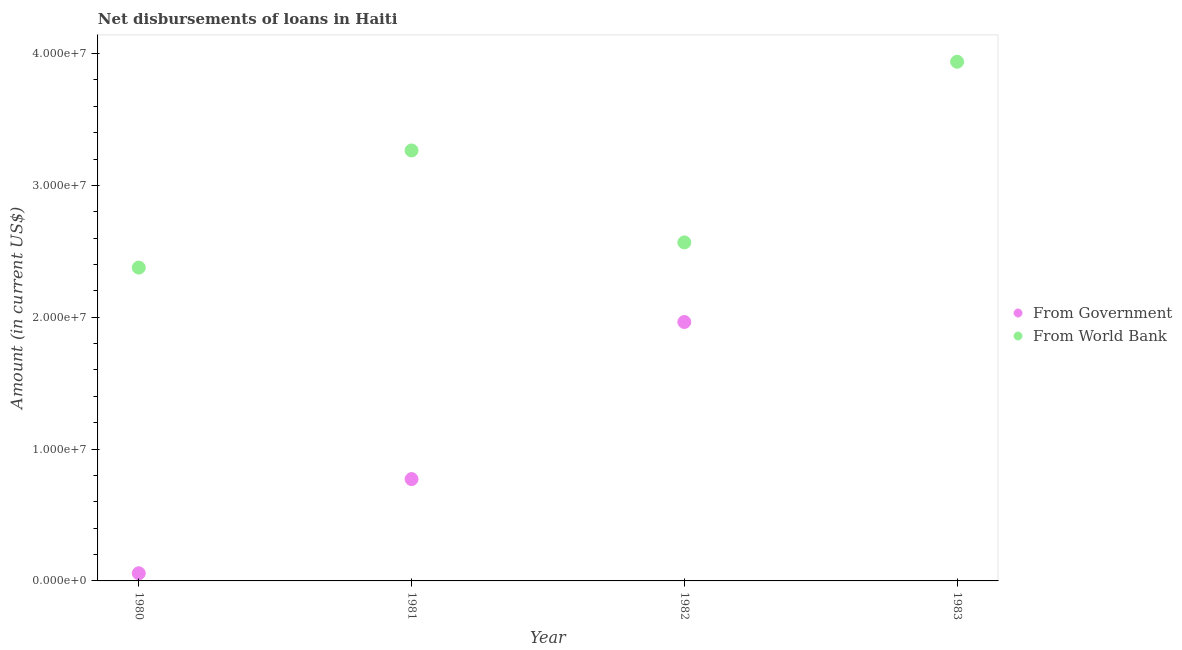What is the net disbursements of loan from world bank in 1983?
Provide a succinct answer. 3.94e+07. Across all years, what is the maximum net disbursements of loan from world bank?
Offer a terse response. 3.94e+07. Across all years, what is the minimum net disbursements of loan from world bank?
Provide a short and direct response. 2.38e+07. In which year was the net disbursements of loan from world bank maximum?
Offer a terse response. 1983. What is the total net disbursements of loan from government in the graph?
Your response must be concise. 2.79e+07. What is the difference between the net disbursements of loan from world bank in 1981 and that in 1982?
Make the answer very short. 6.97e+06. What is the difference between the net disbursements of loan from government in 1983 and the net disbursements of loan from world bank in 1980?
Your answer should be very brief. -2.38e+07. What is the average net disbursements of loan from government per year?
Your response must be concise. 6.99e+06. In the year 1982, what is the difference between the net disbursements of loan from world bank and net disbursements of loan from government?
Ensure brevity in your answer.  6.04e+06. In how many years, is the net disbursements of loan from world bank greater than 16000000 US$?
Your response must be concise. 4. What is the ratio of the net disbursements of loan from government in 1980 to that in 1981?
Keep it short and to the point. 0.08. What is the difference between the highest and the second highest net disbursements of loan from world bank?
Ensure brevity in your answer.  6.73e+06. What is the difference between the highest and the lowest net disbursements of loan from government?
Make the answer very short. 1.96e+07. In how many years, is the net disbursements of loan from government greater than the average net disbursements of loan from government taken over all years?
Keep it short and to the point. 2. Is the sum of the net disbursements of loan from government in 1981 and 1982 greater than the maximum net disbursements of loan from world bank across all years?
Your answer should be very brief. No. Does the net disbursements of loan from government monotonically increase over the years?
Keep it short and to the point. No. Is the net disbursements of loan from government strictly greater than the net disbursements of loan from world bank over the years?
Make the answer very short. No. Is the net disbursements of loan from world bank strictly less than the net disbursements of loan from government over the years?
Keep it short and to the point. No. Does the graph contain any zero values?
Your response must be concise. Yes. Does the graph contain grids?
Make the answer very short. No. What is the title of the graph?
Give a very brief answer. Net disbursements of loans in Haiti. What is the label or title of the Y-axis?
Offer a terse response. Amount (in current US$). What is the Amount (in current US$) in From Government in 1980?
Give a very brief answer. 5.82e+05. What is the Amount (in current US$) in From World Bank in 1980?
Your answer should be compact. 2.38e+07. What is the Amount (in current US$) of From Government in 1981?
Offer a terse response. 7.72e+06. What is the Amount (in current US$) in From World Bank in 1981?
Keep it short and to the point. 3.27e+07. What is the Amount (in current US$) in From Government in 1982?
Your response must be concise. 1.96e+07. What is the Amount (in current US$) in From World Bank in 1982?
Offer a very short reply. 2.57e+07. What is the Amount (in current US$) in From Government in 1983?
Ensure brevity in your answer.  0. What is the Amount (in current US$) in From World Bank in 1983?
Provide a short and direct response. 3.94e+07. Across all years, what is the maximum Amount (in current US$) in From Government?
Keep it short and to the point. 1.96e+07. Across all years, what is the maximum Amount (in current US$) of From World Bank?
Your answer should be very brief. 3.94e+07. Across all years, what is the minimum Amount (in current US$) of From Government?
Offer a terse response. 0. Across all years, what is the minimum Amount (in current US$) of From World Bank?
Offer a very short reply. 2.38e+07. What is the total Amount (in current US$) of From Government in the graph?
Your response must be concise. 2.79e+07. What is the total Amount (in current US$) in From World Bank in the graph?
Give a very brief answer. 1.21e+08. What is the difference between the Amount (in current US$) in From Government in 1980 and that in 1981?
Your answer should be very brief. -7.14e+06. What is the difference between the Amount (in current US$) in From World Bank in 1980 and that in 1981?
Ensure brevity in your answer.  -8.88e+06. What is the difference between the Amount (in current US$) in From Government in 1980 and that in 1982?
Your answer should be very brief. -1.91e+07. What is the difference between the Amount (in current US$) of From World Bank in 1980 and that in 1982?
Your answer should be compact. -1.91e+06. What is the difference between the Amount (in current US$) in From World Bank in 1980 and that in 1983?
Provide a short and direct response. -1.56e+07. What is the difference between the Amount (in current US$) in From Government in 1981 and that in 1982?
Ensure brevity in your answer.  -1.19e+07. What is the difference between the Amount (in current US$) in From World Bank in 1981 and that in 1982?
Provide a succinct answer. 6.97e+06. What is the difference between the Amount (in current US$) in From World Bank in 1981 and that in 1983?
Provide a short and direct response. -6.73e+06. What is the difference between the Amount (in current US$) of From World Bank in 1982 and that in 1983?
Offer a terse response. -1.37e+07. What is the difference between the Amount (in current US$) in From Government in 1980 and the Amount (in current US$) in From World Bank in 1981?
Provide a succinct answer. -3.21e+07. What is the difference between the Amount (in current US$) in From Government in 1980 and the Amount (in current US$) in From World Bank in 1982?
Offer a very short reply. -2.51e+07. What is the difference between the Amount (in current US$) in From Government in 1980 and the Amount (in current US$) in From World Bank in 1983?
Provide a short and direct response. -3.88e+07. What is the difference between the Amount (in current US$) in From Government in 1981 and the Amount (in current US$) in From World Bank in 1982?
Offer a very short reply. -1.80e+07. What is the difference between the Amount (in current US$) of From Government in 1981 and the Amount (in current US$) of From World Bank in 1983?
Make the answer very short. -3.17e+07. What is the difference between the Amount (in current US$) in From Government in 1982 and the Amount (in current US$) in From World Bank in 1983?
Ensure brevity in your answer.  -1.97e+07. What is the average Amount (in current US$) in From Government per year?
Ensure brevity in your answer.  6.99e+06. What is the average Amount (in current US$) in From World Bank per year?
Provide a short and direct response. 3.04e+07. In the year 1980, what is the difference between the Amount (in current US$) of From Government and Amount (in current US$) of From World Bank?
Provide a succinct answer. -2.32e+07. In the year 1981, what is the difference between the Amount (in current US$) in From Government and Amount (in current US$) in From World Bank?
Offer a terse response. -2.49e+07. In the year 1982, what is the difference between the Amount (in current US$) in From Government and Amount (in current US$) in From World Bank?
Your answer should be very brief. -6.04e+06. What is the ratio of the Amount (in current US$) of From Government in 1980 to that in 1981?
Your response must be concise. 0.08. What is the ratio of the Amount (in current US$) of From World Bank in 1980 to that in 1981?
Provide a short and direct response. 0.73. What is the ratio of the Amount (in current US$) in From Government in 1980 to that in 1982?
Your response must be concise. 0.03. What is the ratio of the Amount (in current US$) in From World Bank in 1980 to that in 1982?
Offer a very short reply. 0.93. What is the ratio of the Amount (in current US$) in From World Bank in 1980 to that in 1983?
Give a very brief answer. 0.6. What is the ratio of the Amount (in current US$) in From Government in 1981 to that in 1982?
Your answer should be compact. 0.39. What is the ratio of the Amount (in current US$) of From World Bank in 1981 to that in 1982?
Provide a succinct answer. 1.27. What is the ratio of the Amount (in current US$) in From World Bank in 1981 to that in 1983?
Your answer should be compact. 0.83. What is the ratio of the Amount (in current US$) in From World Bank in 1982 to that in 1983?
Give a very brief answer. 0.65. What is the difference between the highest and the second highest Amount (in current US$) of From Government?
Ensure brevity in your answer.  1.19e+07. What is the difference between the highest and the second highest Amount (in current US$) of From World Bank?
Your answer should be very brief. 6.73e+06. What is the difference between the highest and the lowest Amount (in current US$) of From Government?
Provide a short and direct response. 1.96e+07. What is the difference between the highest and the lowest Amount (in current US$) in From World Bank?
Your answer should be very brief. 1.56e+07. 